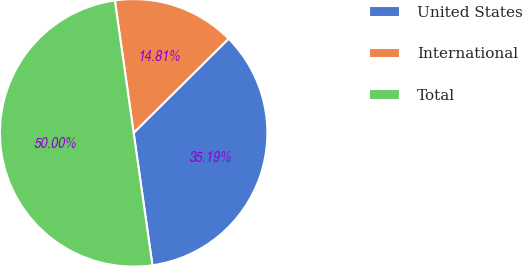Convert chart. <chart><loc_0><loc_0><loc_500><loc_500><pie_chart><fcel>United States<fcel>International<fcel>Total<nl><fcel>35.19%<fcel>14.81%<fcel>50.0%<nl></chart> 